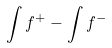Convert formula to latex. <formula><loc_0><loc_0><loc_500><loc_500>\int f ^ { + } - \int f ^ { - }</formula> 